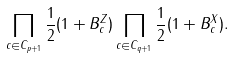<formula> <loc_0><loc_0><loc_500><loc_500>\prod _ { c \in C _ { p + 1 } } \frac { 1 } { 2 } ( 1 + B _ { c } ^ { Z } ) \prod _ { c \in C _ { q + 1 } } \frac { 1 } { 2 } ( 1 + B _ { c } ^ { X } ) .</formula> 